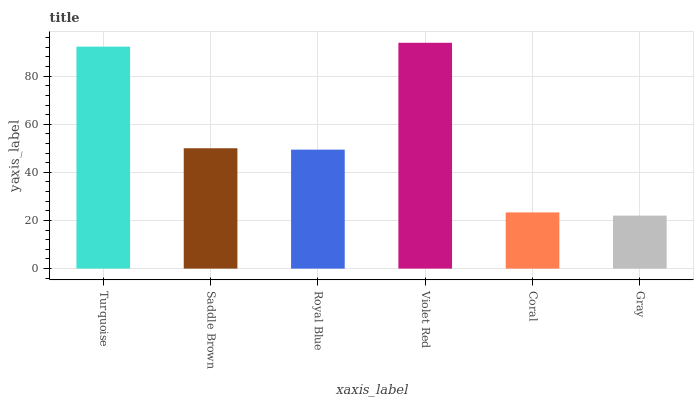Is Violet Red the maximum?
Answer yes or no. Yes. Is Saddle Brown the minimum?
Answer yes or no. No. Is Saddle Brown the maximum?
Answer yes or no. No. Is Turquoise greater than Saddle Brown?
Answer yes or no. Yes. Is Saddle Brown less than Turquoise?
Answer yes or no. Yes. Is Saddle Brown greater than Turquoise?
Answer yes or no. No. Is Turquoise less than Saddle Brown?
Answer yes or no. No. Is Saddle Brown the high median?
Answer yes or no. Yes. Is Royal Blue the low median?
Answer yes or no. Yes. Is Royal Blue the high median?
Answer yes or no. No. Is Turquoise the low median?
Answer yes or no. No. 